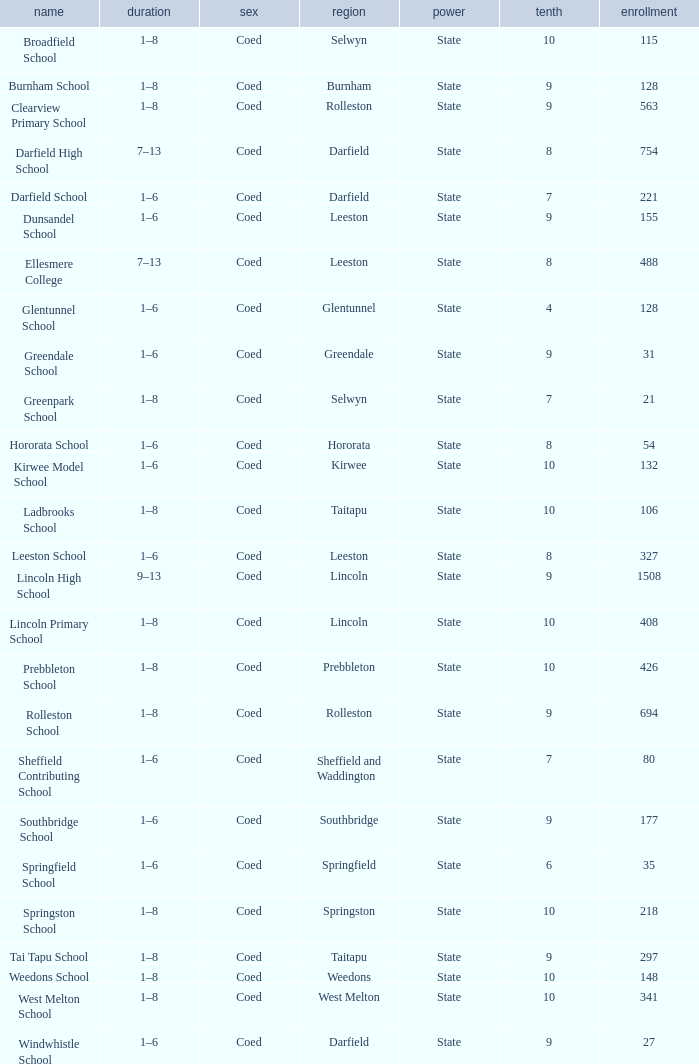Which name has a Roll larger than 297, and Years of 7–13? Darfield High School, Ellesmere College. 